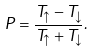<formula> <loc_0><loc_0><loc_500><loc_500>P = \frac { T _ { \uparrow } - T _ { \downarrow } } { T _ { \uparrow } + T _ { \downarrow } } .</formula> 